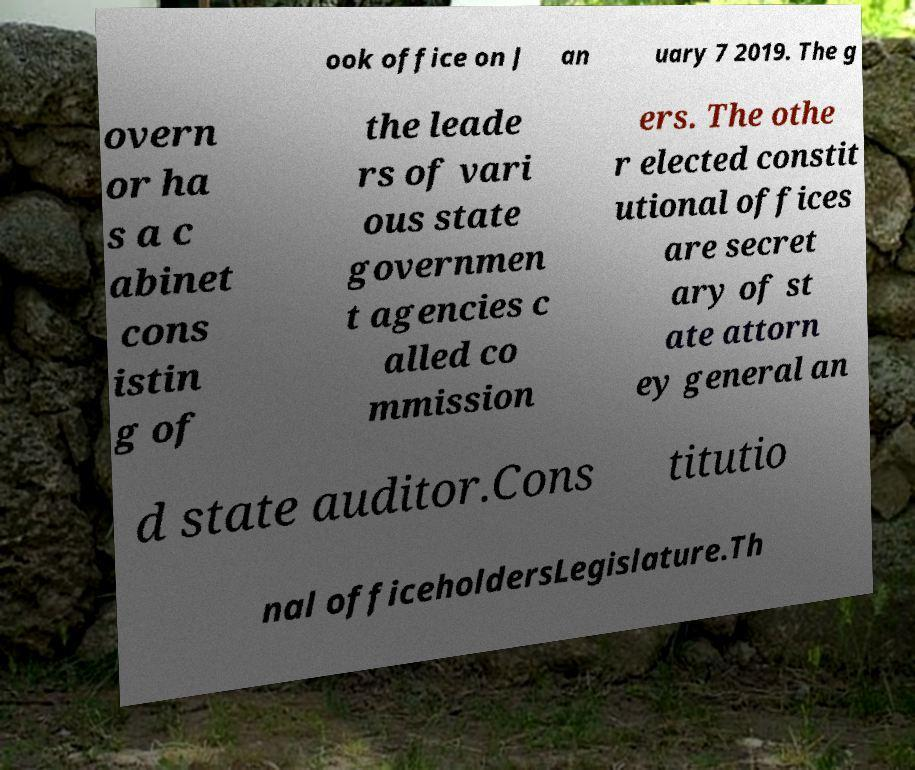Could you assist in decoding the text presented in this image and type it out clearly? ook office on J an uary 7 2019. The g overn or ha s a c abinet cons istin g of the leade rs of vari ous state governmen t agencies c alled co mmission ers. The othe r elected constit utional offices are secret ary of st ate attorn ey general an d state auditor.Cons titutio nal officeholdersLegislature.Th 